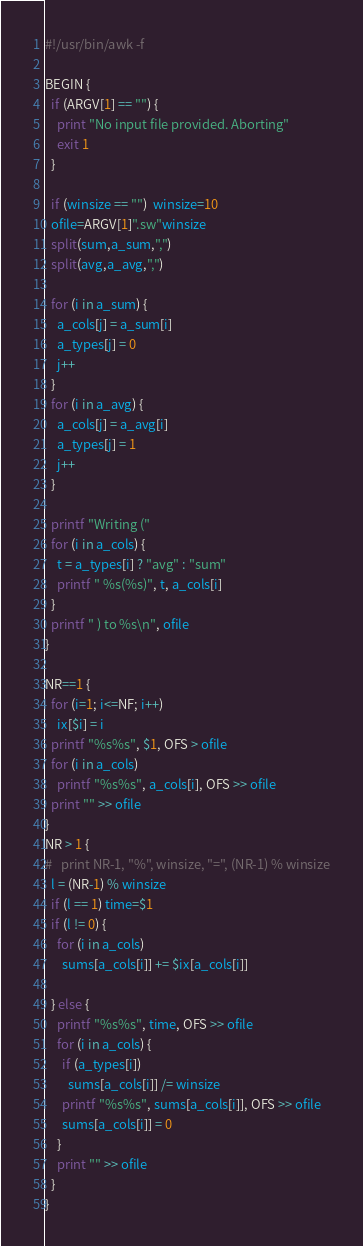<code> <loc_0><loc_0><loc_500><loc_500><_Awk_>#!/usr/bin/awk -f

BEGIN {
  if (ARGV[1] == "") {
    print "No input file provided. Aborting"
    exit 1
  }
    
  if (winsize == "")  winsize=10
  ofile=ARGV[1]".sw"winsize
  split(sum,a_sum,",")
  split(avg,a_avg,",")
  
  for (i in a_sum) {
    a_cols[j] = a_sum[i]
    a_types[j] = 0
    j++
  }
  for (i in a_avg) {
    a_cols[j] = a_avg[i]
    a_types[j] = 1
    j++
  }
  
  printf "Writing ("
  for (i in a_cols) {
    t = a_types[i] ? "avg" : "sum"
    printf " %s(%s)", t, a_cols[i]
  }
  printf " ) to %s\n", ofile
}

NR==1 {
  for (i=1; i<=NF; i++)
    ix[$i] = i
  printf "%s%s", $1, OFS > ofile
  for (i in a_cols)
    printf "%s%s", a_cols[i], OFS >> ofile
  print "" >> ofile
}
NR > 1 {
#   print NR-1, "%", winsize, "=", (NR-1) % winsize
  l = (NR-1) % winsize
  if (l == 1) time=$1
  if (l != 0) {
    for (i in a_cols)
      sums[a_cols[i]] += $ix[a_cols[i]]
      
  } else {
    printf "%s%s", time, OFS >> ofile
    for (i in a_cols) {
      if (a_types[i])
        sums[a_cols[i]] /= winsize
      printf "%s%s", sums[a_cols[i]], OFS >> ofile
      sums[a_cols[i]] = 0
    }
    print "" >> ofile
  }
}
</code> 